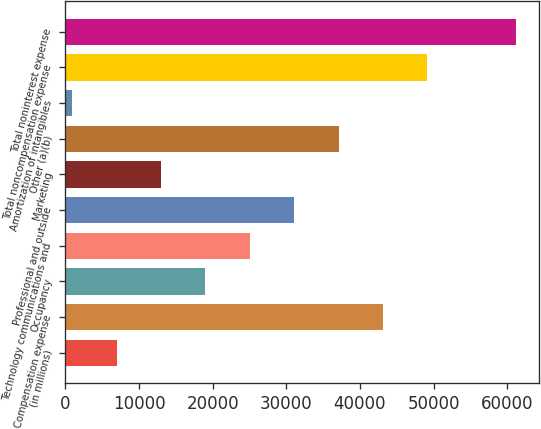<chart> <loc_0><loc_0><loc_500><loc_500><bar_chart><fcel>(in millions)<fcel>Compensation expense<fcel>Occupancy<fcel>Technology communications and<fcel>Professional and outside<fcel>Marketing<fcel>Other (a)(b)<fcel>Amortization of intangibles<fcel>Total noncompensation expense<fcel>Total noninterest expense<nl><fcel>6962<fcel>43118<fcel>19014<fcel>25040<fcel>31066<fcel>12988<fcel>37092<fcel>936<fcel>49144<fcel>61196<nl></chart> 